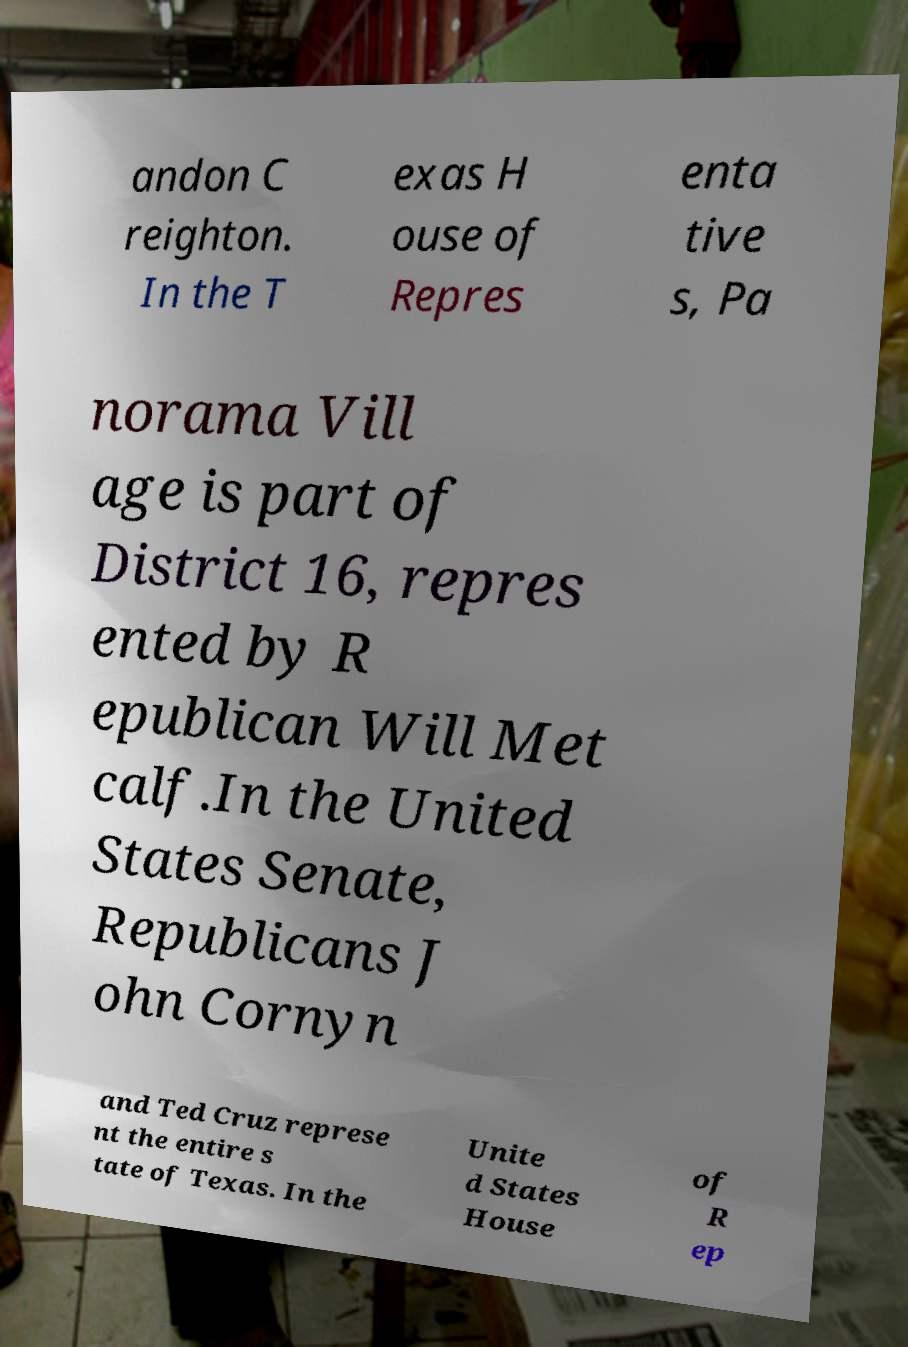Can you read and provide the text displayed in the image?This photo seems to have some interesting text. Can you extract and type it out for me? andon C reighton. In the T exas H ouse of Repres enta tive s, Pa norama Vill age is part of District 16, repres ented by R epublican Will Met calf.In the United States Senate, Republicans J ohn Cornyn and Ted Cruz represe nt the entire s tate of Texas. In the Unite d States House of R ep 